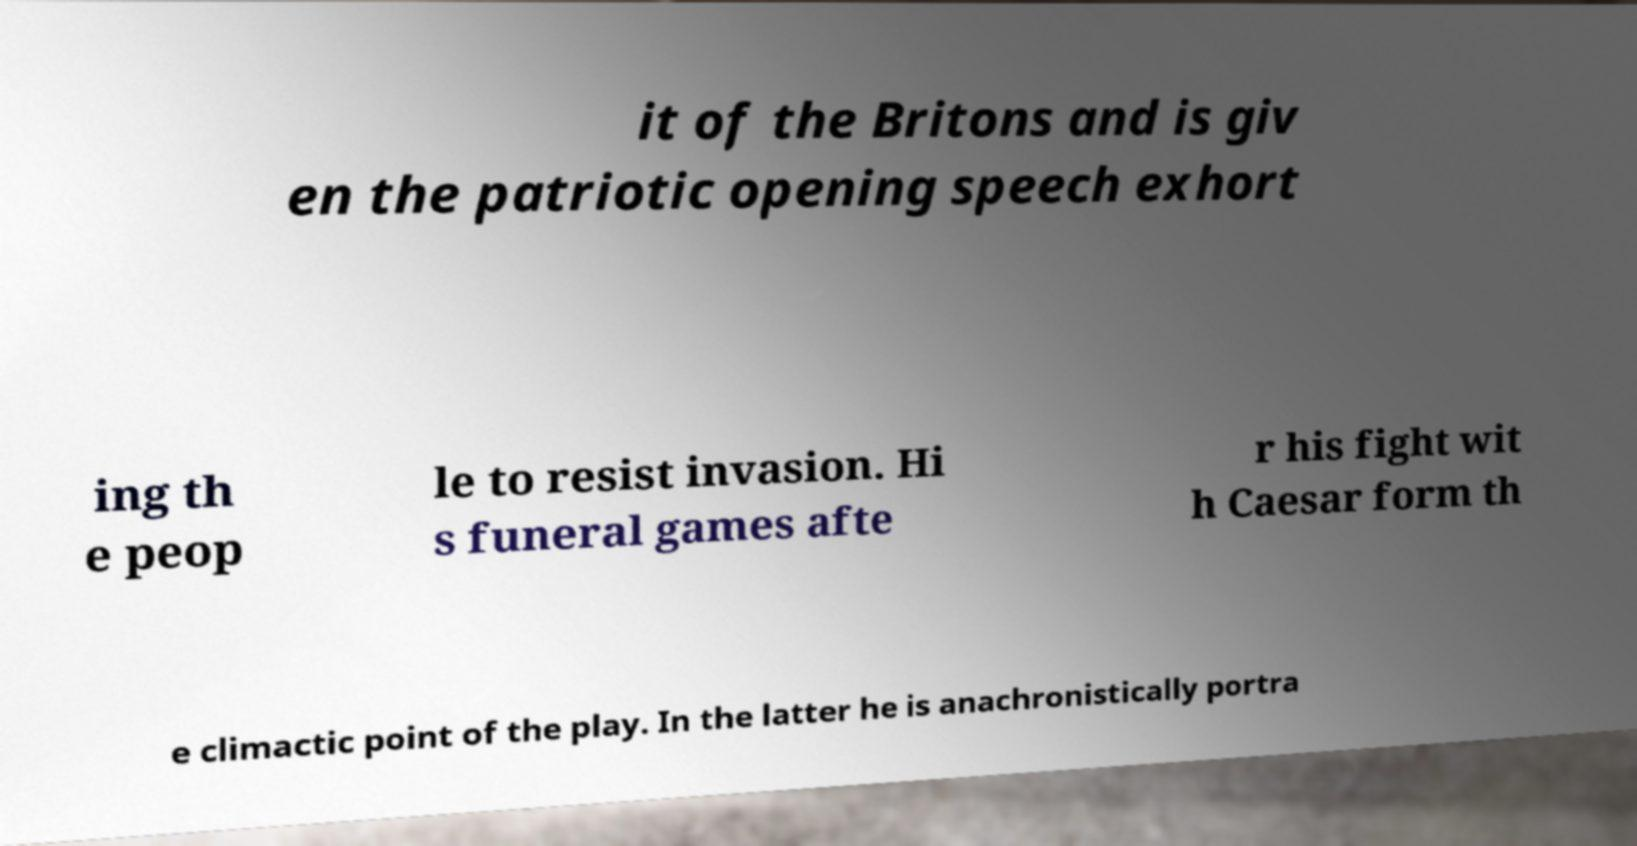Could you extract and type out the text from this image? it of the Britons and is giv en the patriotic opening speech exhort ing th e peop le to resist invasion. Hi s funeral games afte r his fight wit h Caesar form th e climactic point of the play. In the latter he is anachronistically portra 